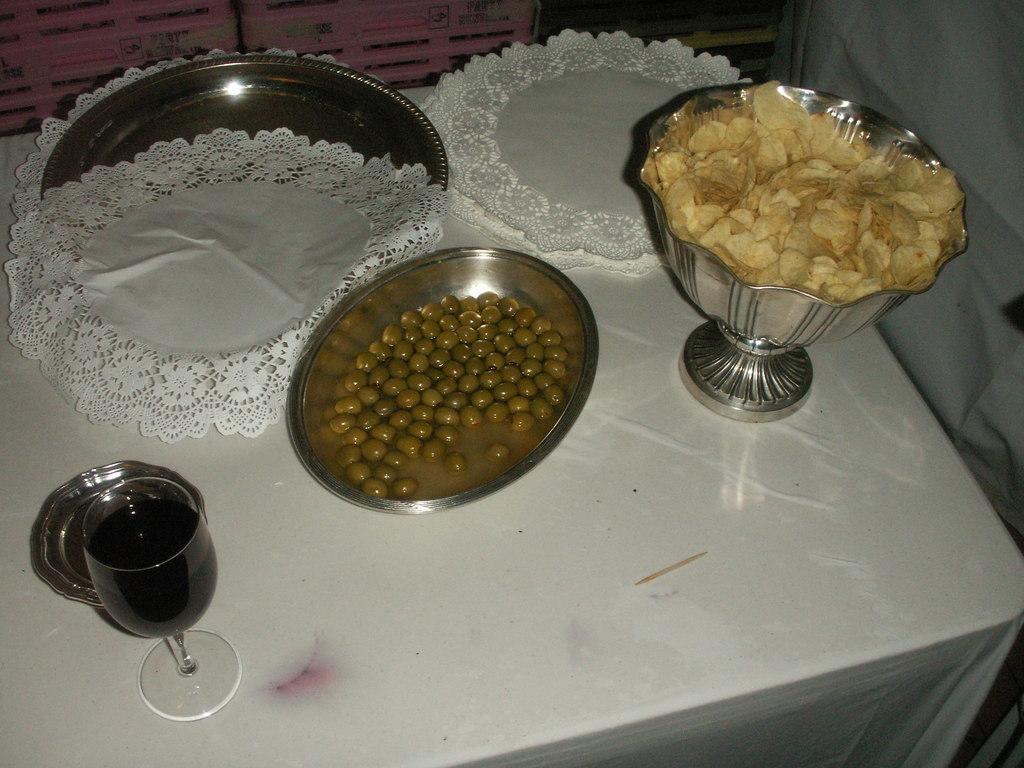Can you describe this image briefly? In this image there is a plate, beside the plate there are few clothes, chips in a bowl, a food item in another bowl, glass drink and a small plate are placed on a table. 